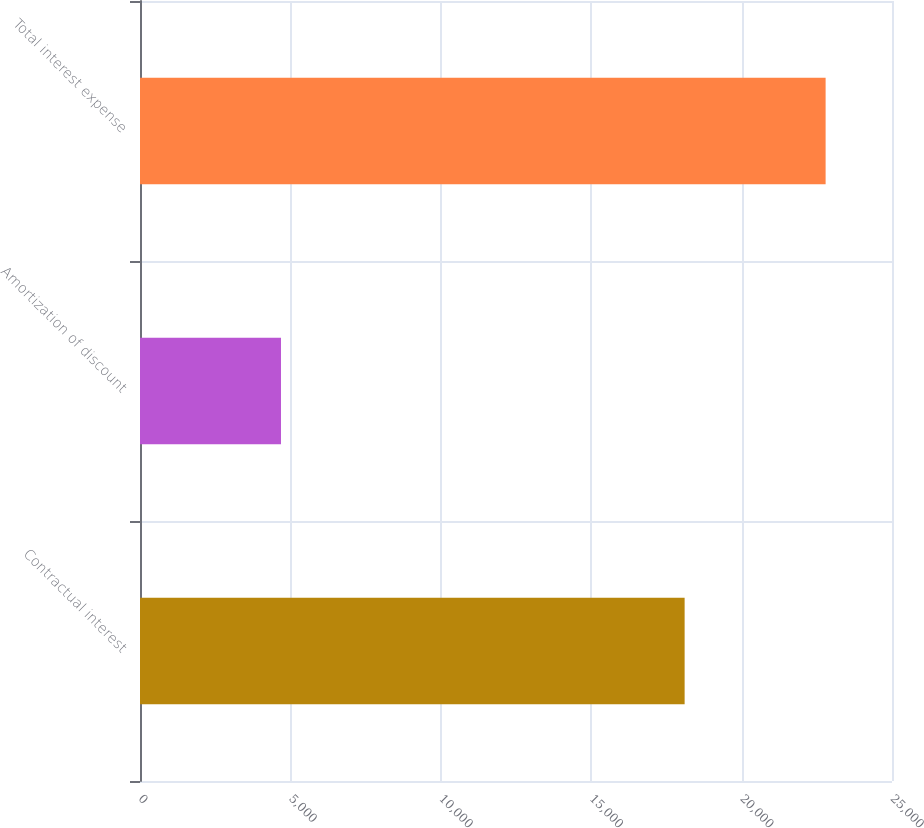<chart> <loc_0><loc_0><loc_500><loc_500><bar_chart><fcel>Contractual interest<fcel>Amortization of discount<fcel>Total interest expense<nl><fcel>18106<fcel>4687<fcel>22793<nl></chart> 